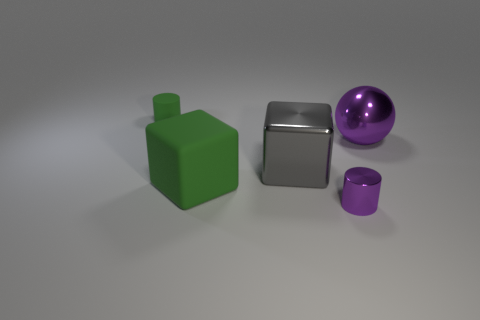Add 1 large blue rubber blocks. How many objects exist? 6 Subtract all balls. How many objects are left? 4 Subtract 0 gray cylinders. How many objects are left? 5 Subtract all big brown shiny cylinders. Subtract all matte cylinders. How many objects are left? 4 Add 2 gray shiny objects. How many gray shiny objects are left? 3 Add 4 large rubber things. How many large rubber things exist? 5 